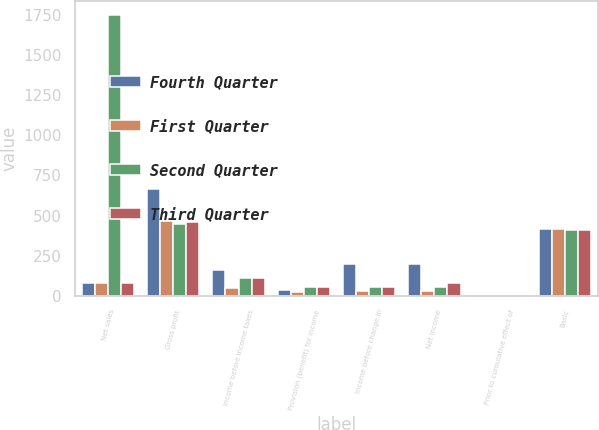Convert chart to OTSL. <chart><loc_0><loc_0><loc_500><loc_500><stacked_bar_chart><ecel><fcel>Net sales<fcel>Gross profit<fcel>Income before income taxes<fcel>Provision (benefit) for income<fcel>Income before change in<fcel>Net income<fcel>Prior to cumulative effect of<fcel>Basic<nl><fcel>Fourth Quarter<fcel>78<fcel>667<fcel>161<fcel>38<fcel>199<fcel>199<fcel>0.48<fcel>415<nl><fcel>First Quarter<fcel>78<fcel>463<fcel>51<fcel>21<fcel>30<fcel>30<fcel>0.07<fcel>413<nl><fcel>Second Quarter<fcel>1753<fcel>450<fcel>108<fcel>56<fcel>52<fcel>52<fcel>0.13<fcel>411<nl><fcel>Third Quarter<fcel>78<fcel>458<fcel>108<fcel>56<fcel>52<fcel>78<fcel>0.13<fcel>410<nl></chart> 